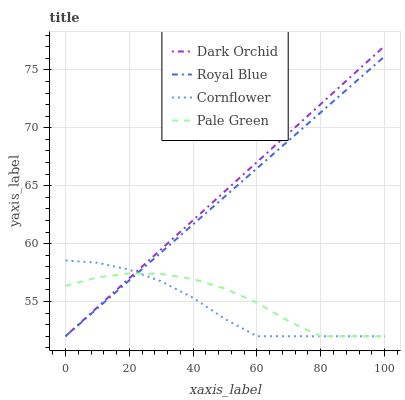Does Pale Green have the minimum area under the curve?
Answer yes or no. No. Does Pale Green have the maximum area under the curve?
Answer yes or no. No. Is Pale Green the smoothest?
Answer yes or no. No. Is Dark Orchid the roughest?
Answer yes or no. No. Does Pale Green have the highest value?
Answer yes or no. No. 